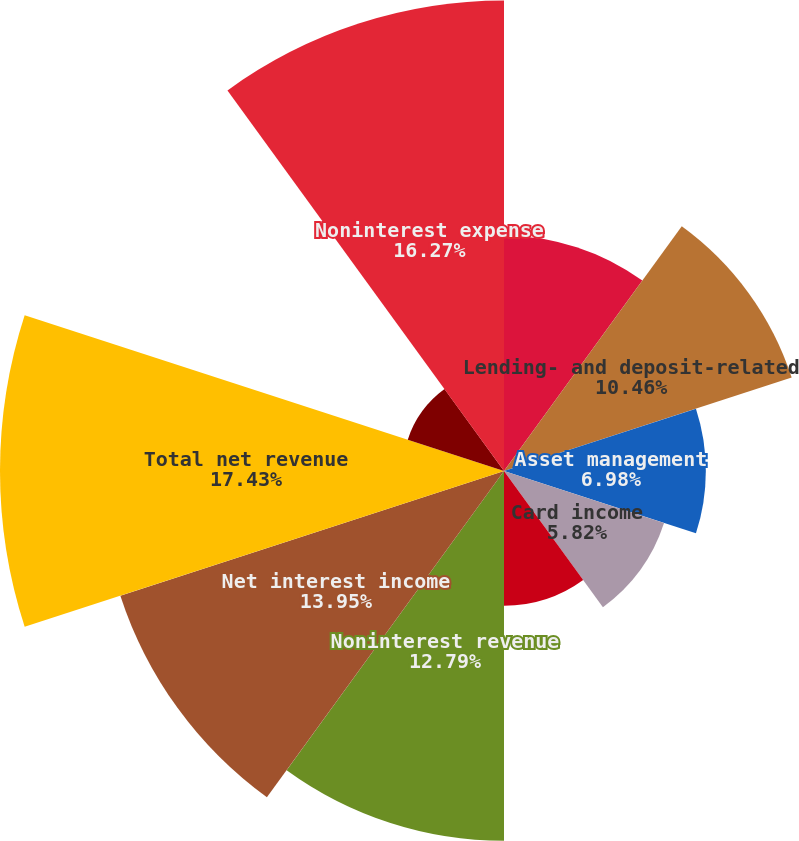Convert chart. <chart><loc_0><loc_0><loc_500><loc_500><pie_chart><fcel>(in millions except ratios)<fcel>Lending- and deposit-related<fcel>Asset management<fcel>Card income<fcel>All other income<fcel>Noninterest revenue<fcel>Net interest income<fcel>Total net revenue<fcel>Provision for credit losses<fcel>Noninterest expense<nl><fcel>8.14%<fcel>10.46%<fcel>6.98%<fcel>5.82%<fcel>4.66%<fcel>12.79%<fcel>13.95%<fcel>17.43%<fcel>3.5%<fcel>16.27%<nl></chart> 